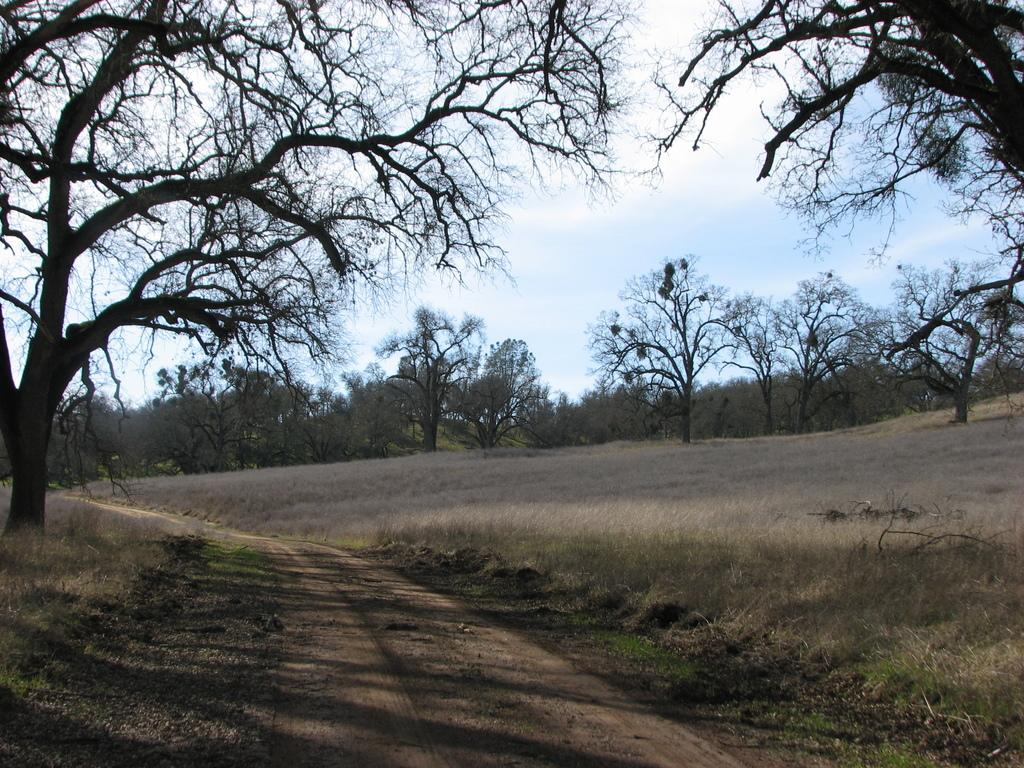What is the main feature in the middle of the image? There is a path in the middle of the image. What type of vegetation is present on either side of the path? Trees are present on either side of the path. What is the ground covered with in the image? Grass is visible on the ground. What can be seen in the background of the image? There are trees in the background of the image. What is visible in the sky in the image? Clouds are visible in the sky. How does the person in the image tramp on the grass? There is no person present in the image, so it is not possible to determine how someone might tramp on the grass. 